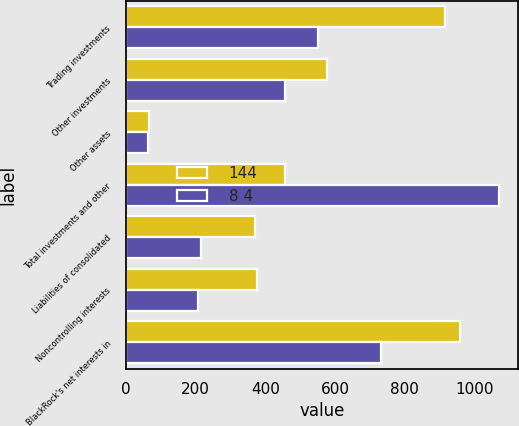Convert chart to OTSL. <chart><loc_0><loc_0><loc_500><loc_500><stacked_bar_chart><ecel><fcel>Trading investments<fcel>Other investments<fcel>Other assets<fcel>Total investments and other<fcel>Liabilities of consolidated<fcel>Noncontrolling interests<fcel>BlackRock's net interests in<nl><fcel>144<fcel>915<fcel>578<fcel>66<fcel>456<fcel>369<fcel>375<fcel>959<nl><fcel>8 4<fcel>552<fcel>456<fcel>63<fcel>1071<fcel>216<fcel>207<fcel>732<nl></chart> 